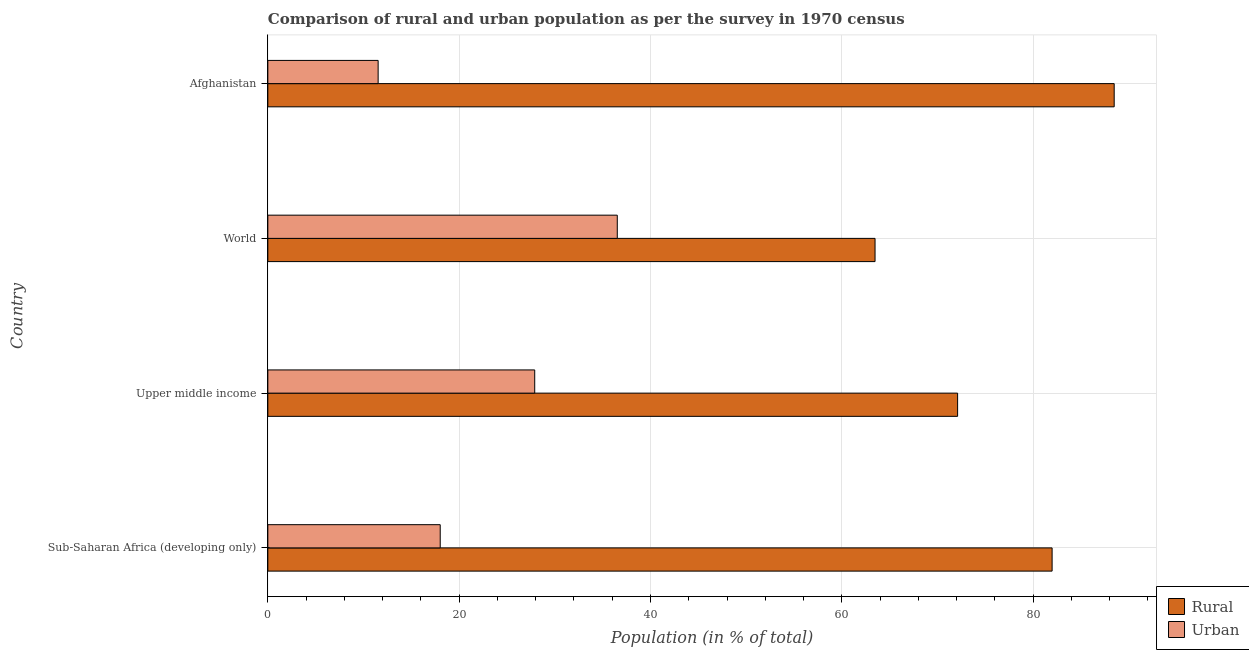How many groups of bars are there?
Provide a short and direct response. 4. Are the number of bars per tick equal to the number of legend labels?
Provide a short and direct response. Yes. Are the number of bars on each tick of the Y-axis equal?
Your answer should be very brief. Yes. How many bars are there on the 4th tick from the top?
Offer a terse response. 2. How many bars are there on the 3rd tick from the bottom?
Your response must be concise. 2. What is the label of the 2nd group of bars from the top?
Make the answer very short. World. In how many cases, is the number of bars for a given country not equal to the number of legend labels?
Your answer should be compact. 0. What is the urban population in Sub-Saharan Africa (developing only)?
Give a very brief answer. 18.02. Across all countries, what is the maximum rural population?
Keep it short and to the point. 88.47. Across all countries, what is the minimum rural population?
Give a very brief answer. 63.47. In which country was the rural population maximum?
Your answer should be compact. Afghanistan. In which country was the urban population minimum?
Provide a succinct answer. Afghanistan. What is the total rural population in the graph?
Give a very brief answer. 306.03. What is the difference between the rural population in Sub-Saharan Africa (developing only) and that in World?
Make the answer very short. 18.51. What is the difference between the urban population in World and the rural population in Sub-Saharan Africa (developing only)?
Give a very brief answer. -45.45. What is the average rural population per country?
Your answer should be very brief. 76.51. What is the difference between the rural population and urban population in Sub-Saharan Africa (developing only)?
Your answer should be compact. 63.96. In how many countries, is the rural population greater than 28 %?
Make the answer very short. 4. What is the ratio of the rural population in Afghanistan to that in Sub-Saharan Africa (developing only)?
Ensure brevity in your answer.  1.08. Is the rural population in Sub-Saharan Africa (developing only) less than that in Upper middle income?
Provide a succinct answer. No. Is the difference between the rural population in Afghanistan and Upper middle income greater than the difference between the urban population in Afghanistan and Upper middle income?
Provide a short and direct response. Yes. What is the difference between the highest and the second highest rural population?
Your response must be concise. 6.49. What is the difference between the highest and the lowest rural population?
Keep it short and to the point. 25. In how many countries, is the rural population greater than the average rural population taken over all countries?
Keep it short and to the point. 2. Is the sum of the rural population in Sub-Saharan Africa (developing only) and World greater than the maximum urban population across all countries?
Provide a succinct answer. Yes. What does the 1st bar from the top in Upper middle income represents?
Make the answer very short. Urban. What does the 1st bar from the bottom in Sub-Saharan Africa (developing only) represents?
Make the answer very short. Rural. How many bars are there?
Give a very brief answer. 8. Are all the bars in the graph horizontal?
Provide a short and direct response. Yes. How many countries are there in the graph?
Keep it short and to the point. 4. Where does the legend appear in the graph?
Provide a short and direct response. Bottom right. How many legend labels are there?
Give a very brief answer. 2. How are the legend labels stacked?
Your answer should be very brief. Vertical. What is the title of the graph?
Provide a succinct answer. Comparison of rural and urban population as per the survey in 1970 census. What is the label or title of the X-axis?
Offer a very short reply. Population (in % of total). What is the Population (in % of total) of Rural in Sub-Saharan Africa (developing only)?
Your answer should be compact. 81.98. What is the Population (in % of total) of Urban in Sub-Saharan Africa (developing only)?
Offer a very short reply. 18.02. What is the Population (in % of total) in Rural in Upper middle income?
Offer a terse response. 72.1. What is the Population (in % of total) in Urban in Upper middle income?
Your answer should be very brief. 27.9. What is the Population (in % of total) in Rural in World?
Give a very brief answer. 63.47. What is the Population (in % of total) of Urban in World?
Keep it short and to the point. 36.53. What is the Population (in % of total) in Rural in Afghanistan?
Ensure brevity in your answer.  88.47. What is the Population (in % of total) of Urban in Afghanistan?
Offer a terse response. 11.53. Across all countries, what is the maximum Population (in % of total) of Rural?
Offer a very short reply. 88.47. Across all countries, what is the maximum Population (in % of total) of Urban?
Keep it short and to the point. 36.53. Across all countries, what is the minimum Population (in % of total) in Rural?
Give a very brief answer. 63.47. Across all countries, what is the minimum Population (in % of total) of Urban?
Offer a very short reply. 11.53. What is the total Population (in % of total) of Rural in the graph?
Provide a succinct answer. 306.03. What is the total Population (in % of total) of Urban in the graph?
Your answer should be very brief. 93.97. What is the difference between the Population (in % of total) in Rural in Sub-Saharan Africa (developing only) and that in Upper middle income?
Provide a succinct answer. 9.88. What is the difference between the Population (in % of total) of Urban in Sub-Saharan Africa (developing only) and that in Upper middle income?
Keep it short and to the point. -9.88. What is the difference between the Population (in % of total) in Rural in Sub-Saharan Africa (developing only) and that in World?
Offer a very short reply. 18.51. What is the difference between the Population (in % of total) of Urban in Sub-Saharan Africa (developing only) and that in World?
Ensure brevity in your answer.  -18.51. What is the difference between the Population (in % of total) in Rural in Sub-Saharan Africa (developing only) and that in Afghanistan?
Give a very brief answer. -6.49. What is the difference between the Population (in % of total) in Urban in Sub-Saharan Africa (developing only) and that in Afghanistan?
Keep it short and to the point. 6.49. What is the difference between the Population (in % of total) in Rural in Upper middle income and that in World?
Ensure brevity in your answer.  8.63. What is the difference between the Population (in % of total) of Urban in Upper middle income and that in World?
Provide a succinct answer. -8.63. What is the difference between the Population (in % of total) in Rural in Upper middle income and that in Afghanistan?
Your response must be concise. -16.37. What is the difference between the Population (in % of total) in Urban in Upper middle income and that in Afghanistan?
Ensure brevity in your answer.  16.37. What is the difference between the Population (in % of total) in Rural in World and that in Afghanistan?
Your answer should be compact. -25. What is the difference between the Population (in % of total) in Urban in World and that in Afghanistan?
Ensure brevity in your answer.  25. What is the difference between the Population (in % of total) in Rural in Sub-Saharan Africa (developing only) and the Population (in % of total) in Urban in Upper middle income?
Your answer should be compact. 54.09. What is the difference between the Population (in % of total) of Rural in Sub-Saharan Africa (developing only) and the Population (in % of total) of Urban in World?
Keep it short and to the point. 45.45. What is the difference between the Population (in % of total) in Rural in Sub-Saharan Africa (developing only) and the Population (in % of total) in Urban in Afghanistan?
Make the answer very short. 70.45. What is the difference between the Population (in % of total) in Rural in Upper middle income and the Population (in % of total) in Urban in World?
Give a very brief answer. 35.58. What is the difference between the Population (in % of total) of Rural in Upper middle income and the Population (in % of total) of Urban in Afghanistan?
Your answer should be compact. 60.57. What is the difference between the Population (in % of total) of Rural in World and the Population (in % of total) of Urban in Afghanistan?
Give a very brief answer. 51.94. What is the average Population (in % of total) of Rural per country?
Provide a succinct answer. 76.51. What is the average Population (in % of total) in Urban per country?
Your answer should be very brief. 23.49. What is the difference between the Population (in % of total) of Rural and Population (in % of total) of Urban in Sub-Saharan Africa (developing only)?
Offer a very short reply. 63.96. What is the difference between the Population (in % of total) of Rural and Population (in % of total) of Urban in Upper middle income?
Keep it short and to the point. 44.21. What is the difference between the Population (in % of total) of Rural and Population (in % of total) of Urban in World?
Make the answer very short. 26.94. What is the difference between the Population (in % of total) in Rural and Population (in % of total) in Urban in Afghanistan?
Your response must be concise. 76.94. What is the ratio of the Population (in % of total) of Rural in Sub-Saharan Africa (developing only) to that in Upper middle income?
Provide a short and direct response. 1.14. What is the ratio of the Population (in % of total) of Urban in Sub-Saharan Africa (developing only) to that in Upper middle income?
Make the answer very short. 0.65. What is the ratio of the Population (in % of total) of Rural in Sub-Saharan Africa (developing only) to that in World?
Offer a terse response. 1.29. What is the ratio of the Population (in % of total) in Urban in Sub-Saharan Africa (developing only) to that in World?
Your answer should be compact. 0.49. What is the ratio of the Population (in % of total) in Rural in Sub-Saharan Africa (developing only) to that in Afghanistan?
Give a very brief answer. 0.93. What is the ratio of the Population (in % of total) in Urban in Sub-Saharan Africa (developing only) to that in Afghanistan?
Provide a succinct answer. 1.56. What is the ratio of the Population (in % of total) in Rural in Upper middle income to that in World?
Provide a short and direct response. 1.14. What is the ratio of the Population (in % of total) in Urban in Upper middle income to that in World?
Make the answer very short. 0.76. What is the ratio of the Population (in % of total) of Rural in Upper middle income to that in Afghanistan?
Your answer should be compact. 0.81. What is the ratio of the Population (in % of total) in Urban in Upper middle income to that in Afghanistan?
Provide a short and direct response. 2.42. What is the ratio of the Population (in % of total) in Rural in World to that in Afghanistan?
Keep it short and to the point. 0.72. What is the ratio of the Population (in % of total) of Urban in World to that in Afghanistan?
Ensure brevity in your answer.  3.17. What is the difference between the highest and the second highest Population (in % of total) of Rural?
Offer a very short reply. 6.49. What is the difference between the highest and the second highest Population (in % of total) of Urban?
Offer a very short reply. 8.63. What is the difference between the highest and the lowest Population (in % of total) in Rural?
Make the answer very short. 25. What is the difference between the highest and the lowest Population (in % of total) in Urban?
Provide a succinct answer. 25. 